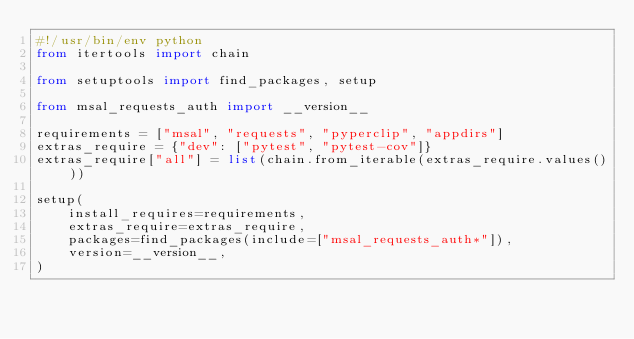<code> <loc_0><loc_0><loc_500><loc_500><_Python_>#!/usr/bin/env python
from itertools import chain

from setuptools import find_packages, setup

from msal_requests_auth import __version__

requirements = ["msal", "requests", "pyperclip", "appdirs"]
extras_require = {"dev": ["pytest", "pytest-cov"]}
extras_require["all"] = list(chain.from_iterable(extras_require.values()))

setup(
    install_requires=requirements,
    extras_require=extras_require,
    packages=find_packages(include=["msal_requests_auth*"]),
    version=__version__,
)
</code> 